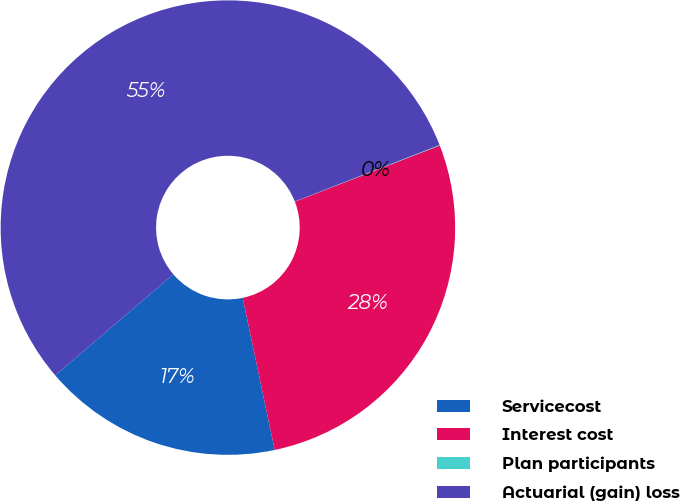Convert chart. <chart><loc_0><loc_0><loc_500><loc_500><pie_chart><fcel>Servicecost<fcel>Interest cost<fcel>Plan participants<fcel>Actuarial (gain) loss<nl><fcel>17.04%<fcel>27.58%<fcel>0.04%<fcel>55.34%<nl></chart> 